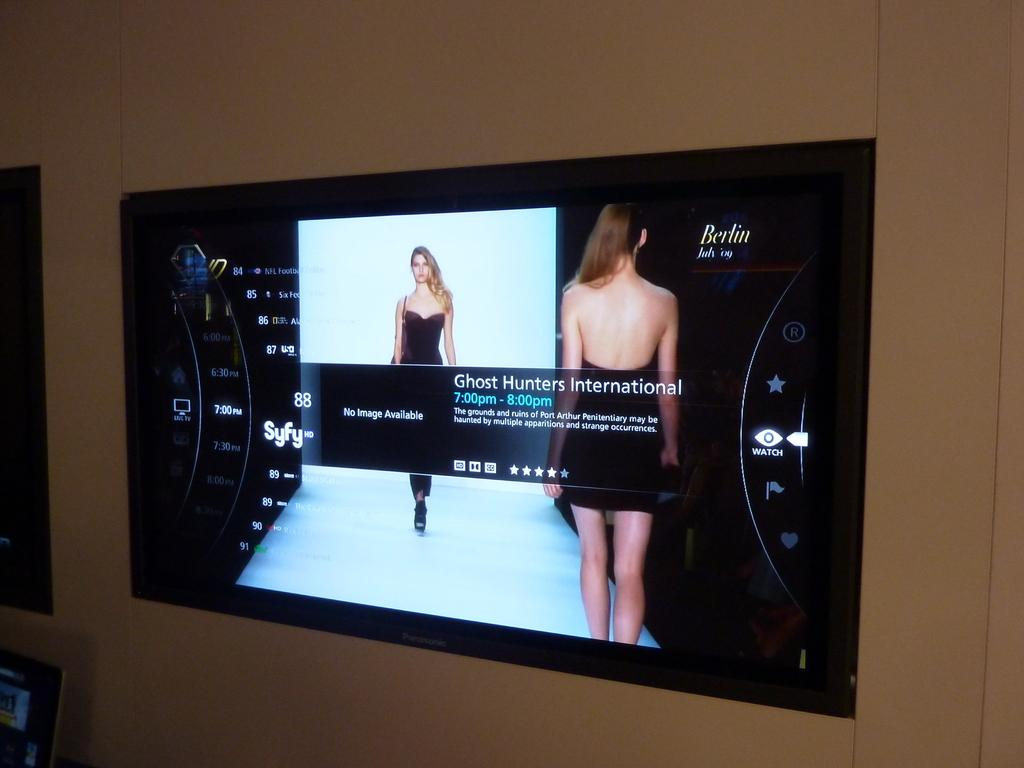<image>
Create a compact narrative representing the image presented. Television Screen that says Berlin July 09 and says Ghost Hunters International 7:00 PM to 8:00 PM. 